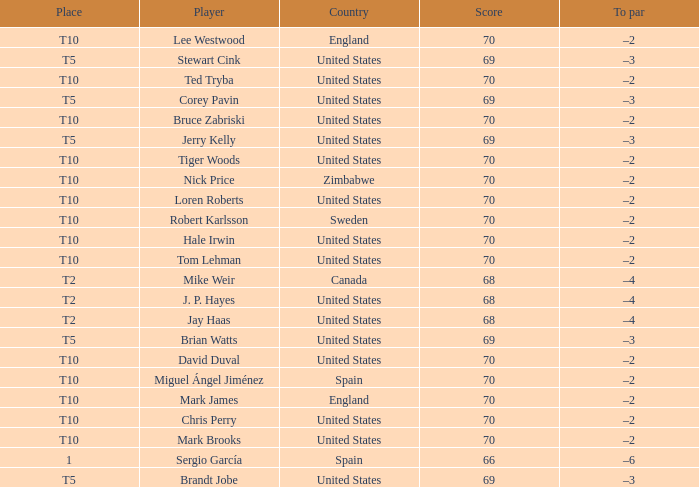What was the To par of the golfer that placed t5? –3, –3, –3, –3, –3. 